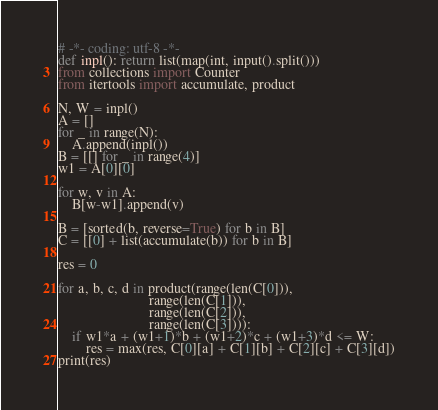<code> <loc_0><loc_0><loc_500><loc_500><_Python_># -*- coding: utf-8 -*-
def inpl(): return list(map(int, input().split()))
from collections import Counter
from itertools import accumulate, product

N, W = inpl()
A = []
for _ in range(N):
    A.append(inpl())
B = [[] for _ in range(4)]
w1 = A[0][0]

for w, v in A:
    B[w-w1].append(v)

B = [sorted(b, reverse=True) for b in B]
C = [[0] + list(accumulate(b)) for b in B]

res = 0

for a, b, c, d in product(range(len(C[0])),
                          range(len(C[1])),
                          range(len(C[2])),
                          range(len(C[3]))):
    if w1*a + (w1+1)*b + (w1+2)*c + (w1+3)*d <= W:
        res = max(res, C[0][a] + C[1][b] + C[2][c] + C[3][d])
print(res)</code> 